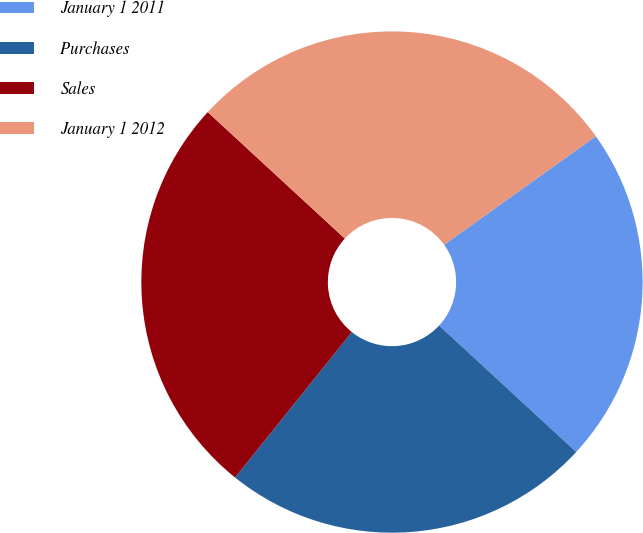<chart> <loc_0><loc_0><loc_500><loc_500><pie_chart><fcel>January 1 2011<fcel>Purchases<fcel>Sales<fcel>January 1 2012<nl><fcel>21.74%<fcel>23.91%<fcel>26.09%<fcel>28.26%<nl></chart> 